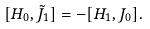<formula> <loc_0><loc_0><loc_500><loc_500>[ H _ { 0 } , \tilde { J } _ { 1 } ] = - [ H _ { 1 } , J _ { 0 } ] .</formula> 